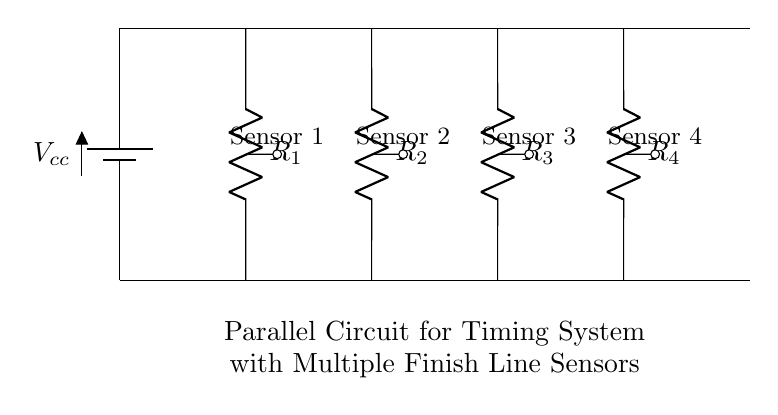What is the total number of resistors in the circuit? The circuit diagram shows four resistors labeled as R1, R2, R3, and R4 connected in parallel. Counting these gives a total of four resistors.
Answer: Four What do the nodes at the top of the resistors represent? The nodes at the top of each resistor connect them to the battery voltage Vcc, which provides the same voltage across each resistor because they are in parallel.
Answer: Battery voltage How does the current through each sensor relate to the total current in the circuit? In a parallel circuit, the total current is the sum of the currents through each branch. Therefore, the total current equals the current through sensor 1 plus the current through sensor 2 plus the current through sensor 3 plus the current through sensor 4.
Answer: Sum of branch currents If the resistance of all sensors is identical, how does changing the resistance affect the total current? Since the sensors have identical resistance, if the resistance is decreased, this increases the branch currents. In a parallel circuit, reducing resistance leads to an increase in total current. Conversely, increasing resistance decreases the total current.
Answer: Inversely proportional Which component can provide the voltage needed for all sensors? The component that provides the voltage for the sensors in the circuit is the battery labeled Vcc. It supplies the necessary potential difference for the resistors.
Answer: Battery What happens to the total resistance if one sensor fails (becomes an open circuit)? In a parallel circuit, if one branch becomes an open circuit (like a failed sensor), it does not significantly affect the total resistance or current since the remaining branches still provide paths for current to flow. The total resistance would increase, but the circuit still operates.
Answer: Increases total resistance 